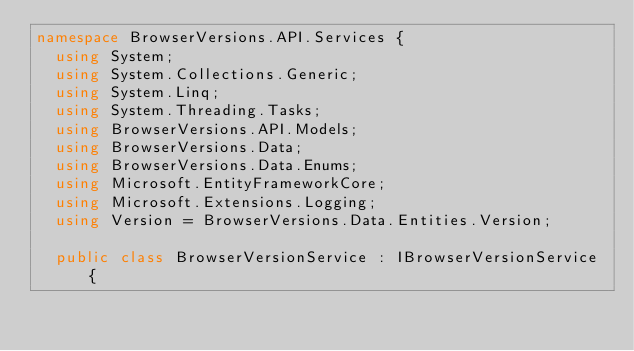<code> <loc_0><loc_0><loc_500><loc_500><_C#_>namespace BrowserVersions.API.Services {
  using System;
  using System.Collections.Generic;
  using System.Linq;
  using System.Threading.Tasks;
  using BrowserVersions.API.Models;
  using BrowserVersions.Data;
  using BrowserVersions.Data.Enums;
  using Microsoft.EntityFrameworkCore;
  using Microsoft.Extensions.Logging;
  using Version = BrowserVersions.Data.Entities.Version;

  public class BrowserVersionService : IBrowserVersionService {</code> 